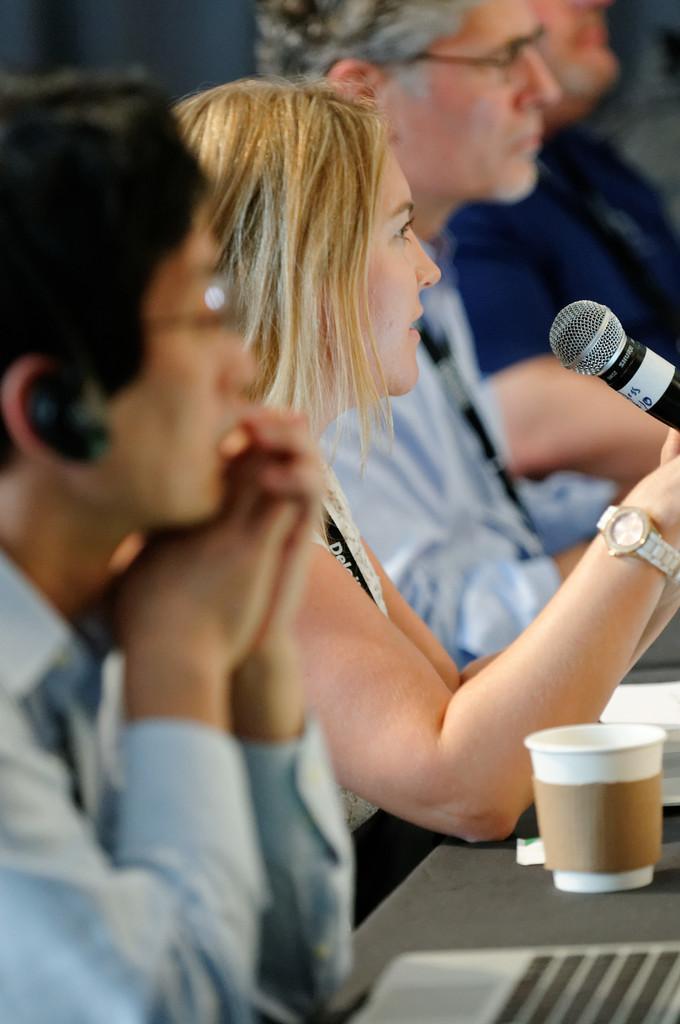How would you summarize this image in a sentence or two? There are four people sitting. This looks like a table with a glass and papers. I think this woman is holding a mike in her hands. This looks like a laptop. 